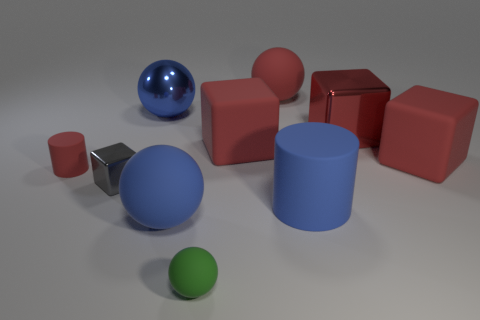There is a sphere that is to the left of the big matte ball that is in front of the small red thing; how many blue spheres are behind it?
Provide a succinct answer. 0. There is a large red thing that is both on the left side of the blue cylinder and in front of the red metallic object; what material is it?
Your answer should be very brief. Rubber. Do the tiny green object and the small thing that is behind the tiny shiny block have the same material?
Provide a succinct answer. Yes. Are there more large red blocks to the left of the red shiny object than tiny gray cubes that are on the right side of the small green rubber object?
Ensure brevity in your answer.  Yes. What is the shape of the small green object?
Your answer should be very brief. Sphere. Do the big blue sphere behind the small red matte cylinder and the red cube to the left of the big cylinder have the same material?
Ensure brevity in your answer.  No. What is the shape of the tiny matte object in front of the tiny red thing?
Your answer should be very brief. Sphere. There is a green rubber thing that is the same shape as the blue metallic object; what size is it?
Offer a terse response. Small. Is the color of the tiny rubber cylinder the same as the large shiny cube?
Offer a terse response. Yes. Is there a red object left of the large blue metallic sphere that is behind the green matte sphere?
Offer a terse response. Yes. 